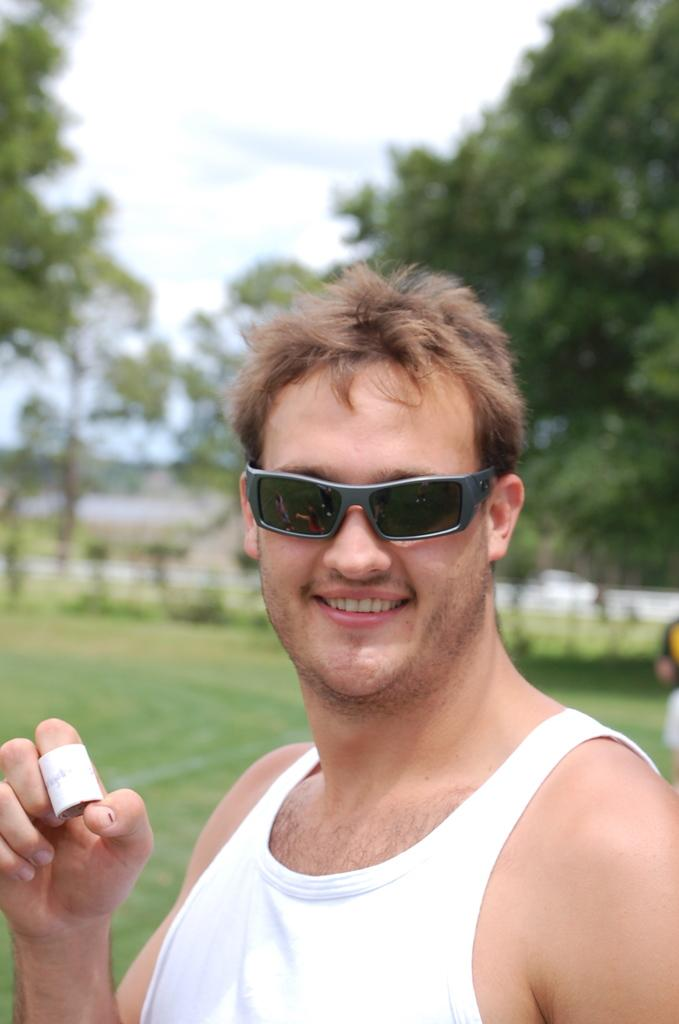Who is the main subject in the image? There is a man in the center of the image. What is the man doing in the image? The man is standing and smiling. What accessory is the man wearing in the image? The man is wearing glasses. What can be seen in the background of the image? There are trees and the sky visible in the background of the image. How many pairs of shoes can be seen in the image? There are no shoes visible in the image; it only features a man standing and smiling. What type of fruit is the man holding in the image? There is no fruit present in the image; the man is not holding anything. 